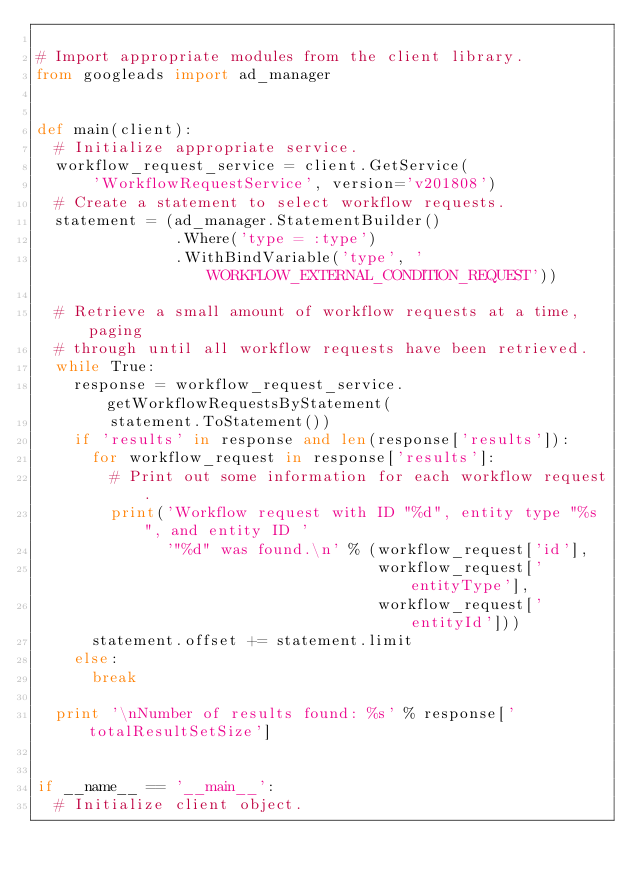Convert code to text. <code><loc_0><loc_0><loc_500><loc_500><_Python_>
# Import appropriate modules from the client library.
from googleads import ad_manager


def main(client):
  # Initialize appropriate service.
  workflow_request_service = client.GetService(
      'WorkflowRequestService', version='v201808')
  # Create a statement to select workflow requests.
  statement = (ad_manager.StatementBuilder()
               .Where('type = :type')
               .WithBindVariable('type', 'WORKFLOW_EXTERNAL_CONDITION_REQUEST'))

  # Retrieve a small amount of workflow requests at a time, paging
  # through until all workflow requests have been retrieved.
  while True:
    response = workflow_request_service.getWorkflowRequestsByStatement(
        statement.ToStatement())
    if 'results' in response and len(response['results']):
      for workflow_request in response['results']:
        # Print out some information for each workflow request.
        print('Workflow request with ID "%d", entity type "%s", and entity ID '
              '"%d" was found.\n' % (workflow_request['id'],
                                     workflow_request['entityType'],
                                     workflow_request['entityId']))
      statement.offset += statement.limit
    else:
      break

  print '\nNumber of results found: %s' % response['totalResultSetSize']


if __name__ == '__main__':
  # Initialize client object.</code> 